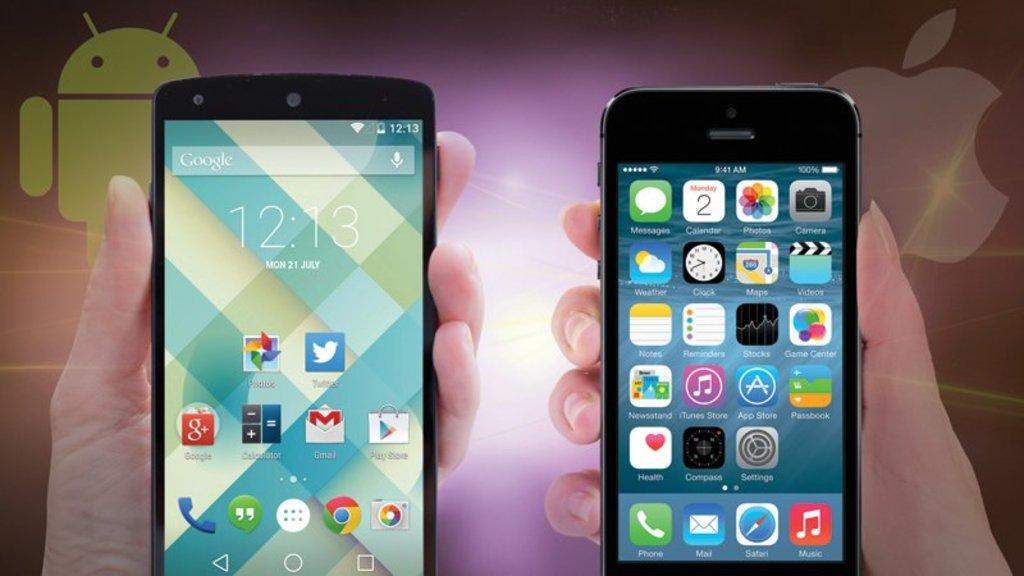What is being held by the hands in the image? The hands in the image are holding mobiles. How was the image created or modified? The image is edited. What can be seen in the background of the image? There are logos in the background of the image. What type of zinc is present in the image? There is no zinc present in the image. How does the image trick the viewer into believing something that is not true? The image does not trick the viewer; it is simply edited, as stated in the facts. 